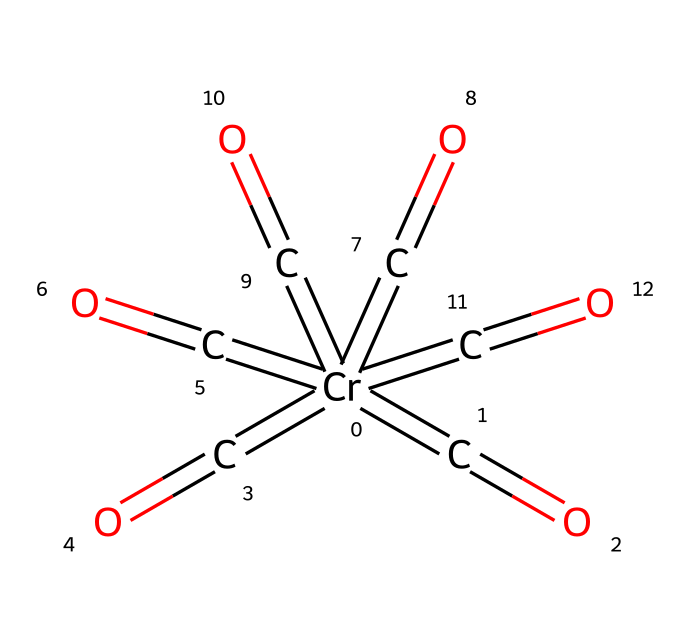What is the central metal atom in this compound? The central metal atom in this compound is located in the middle of the SMILES representation, which indicates a chromium atom designated by [Cr].
Answer: chromium How many carbonyl (C=O) groups are present? The SMILES representation shows multiple =C=O units attached to the chromium, counting them reveals that there are six carbonyl groups.
Answer: six What is the overall coordination number of chromium in this complex? The chromium atom is surrounded by six carbonyl ligands, each forming a bond. Therefore, the coordination number, which totals the number of bonds to the metal, is six.
Answer: six What type of bonding is primarily involved in this compound? This compound primarily involves coordinate covalent bonding between the chromium atom and the carbonyl groups, indicated by the metal-ligand interaction resulting from the formal donation of electron pairs.
Answer: coordinate covalent How many total atoms are there in the molecule? To determine the total number of atoms, add the number of chromium, carbonyl carbons, and oxygen atoms together: 1 chromium, 6 carbons (one for each carbonyl), and 6 oxygens equals a total of 13 atoms.
Answer: thirteen What is the molecular shape around the chromium center? The arrangement of six carbonyl groups around the chromium, considering the sterics and ideal geometry, suggests an octahedral shape, commonly seen in metal complexes with six ligands.
Answer: octahedral Is this complex likely to be stable in air? The presence of multiple carbonyl groups generally indicates that this complex is relatively stable, but the specific stability may vary based on environmental conditions. Generally, chromium hexacarbonyl is known to be stable under atmospheric conditions but may decompose under significant heat or light.
Answer: yes 